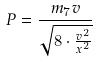<formula> <loc_0><loc_0><loc_500><loc_500>P = \frac { m _ { 7 } v } { \sqrt { 8 \cdot \frac { v ^ { 2 } } { x ^ { 2 } } } }</formula> 